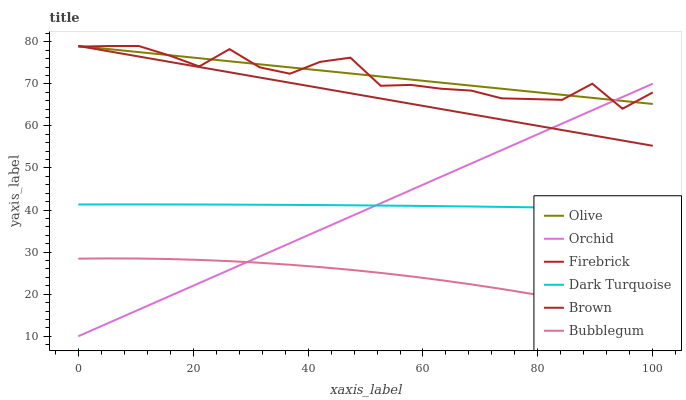Does Bubblegum have the minimum area under the curve?
Answer yes or no. Yes. Does Olive have the maximum area under the curve?
Answer yes or no. Yes. Does Dark Turquoise have the minimum area under the curve?
Answer yes or no. No. Does Dark Turquoise have the maximum area under the curve?
Answer yes or no. No. Is Orchid the smoothest?
Answer yes or no. Yes. Is Firebrick the roughest?
Answer yes or no. Yes. Is Dark Turquoise the smoothest?
Answer yes or no. No. Is Dark Turquoise the roughest?
Answer yes or no. No. Does Orchid have the lowest value?
Answer yes or no. Yes. Does Dark Turquoise have the lowest value?
Answer yes or no. No. Does Olive have the highest value?
Answer yes or no. Yes. Does Dark Turquoise have the highest value?
Answer yes or no. No. Is Bubblegum less than Dark Turquoise?
Answer yes or no. Yes. Is Olive greater than Dark Turquoise?
Answer yes or no. Yes. Does Firebrick intersect Brown?
Answer yes or no. Yes. Is Firebrick less than Brown?
Answer yes or no. No. Is Firebrick greater than Brown?
Answer yes or no. No. Does Bubblegum intersect Dark Turquoise?
Answer yes or no. No. 